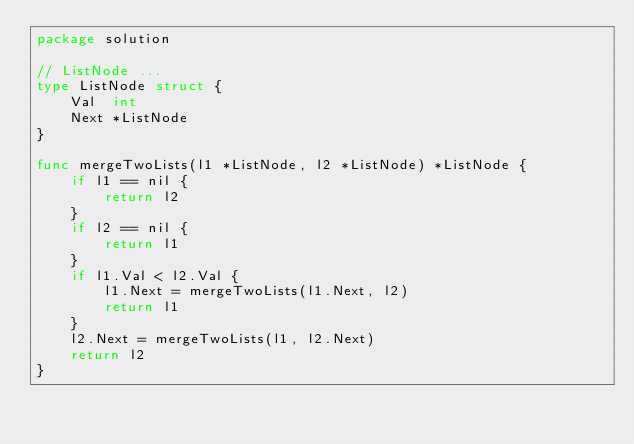Convert code to text. <code><loc_0><loc_0><loc_500><loc_500><_Go_>package solution

// ListNode ...
type ListNode struct {
	Val  int
	Next *ListNode
}

func mergeTwoLists(l1 *ListNode, l2 *ListNode) *ListNode {
	if l1 == nil {
		return l2
	}
	if l2 == nil {
		return l1
	}
	if l1.Val < l2.Val {
		l1.Next = mergeTwoLists(l1.Next, l2)
		return l1
	}
	l2.Next = mergeTwoLists(l1, l2.Next)
	return l2
}
</code> 